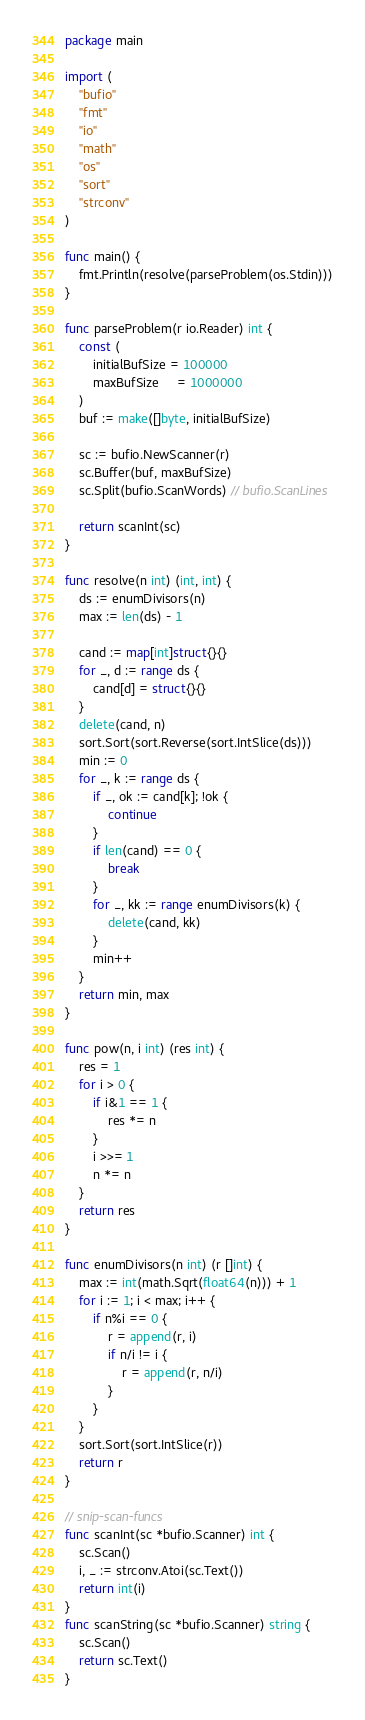<code> <loc_0><loc_0><loc_500><loc_500><_Go_>package main

import (
	"bufio"
	"fmt"
	"io"
	"math"
	"os"
	"sort"
	"strconv"
)

func main() {
	fmt.Println(resolve(parseProblem(os.Stdin)))
}

func parseProblem(r io.Reader) int {
	const (
		initialBufSize = 100000
		maxBufSize     = 1000000
	)
	buf := make([]byte, initialBufSize)

	sc := bufio.NewScanner(r)
	sc.Buffer(buf, maxBufSize)
	sc.Split(bufio.ScanWords) // bufio.ScanLines

	return scanInt(sc)
}

func resolve(n int) (int, int) {
	ds := enumDivisors(n)
	max := len(ds) - 1

	cand := map[int]struct{}{}
	for _, d := range ds {
		cand[d] = struct{}{}
	}
	delete(cand, n)
	sort.Sort(sort.Reverse(sort.IntSlice(ds)))
	min := 0
	for _, k := range ds {
		if _, ok := cand[k]; !ok {
			continue
		}
		if len(cand) == 0 {
			break
		}
		for _, kk := range enumDivisors(k) {
			delete(cand, kk)
		}
		min++
	}
	return min, max
}

func pow(n, i int) (res int) {
	res = 1
	for i > 0 {
		if i&1 == 1 {
			res *= n
		}
		i >>= 1
		n *= n
	}
	return res
}

func enumDivisors(n int) (r []int) {
	max := int(math.Sqrt(float64(n))) + 1
	for i := 1; i < max; i++ {
		if n%i == 0 {
			r = append(r, i)
			if n/i != i {
				r = append(r, n/i)
			}
		}
	}
	sort.Sort(sort.IntSlice(r))
	return r
}

// snip-scan-funcs
func scanInt(sc *bufio.Scanner) int {
	sc.Scan()
	i, _ := strconv.Atoi(sc.Text())
	return int(i)
}
func scanString(sc *bufio.Scanner) string {
	sc.Scan()
	return sc.Text()
}

</code> 